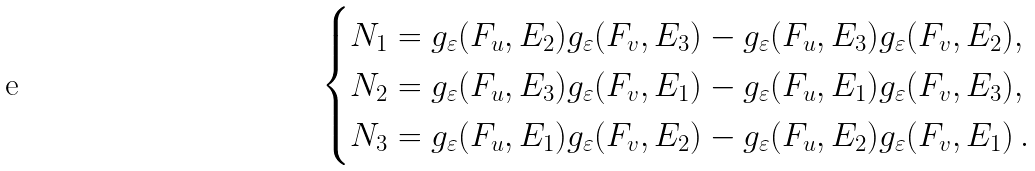Convert formula to latex. <formula><loc_0><loc_0><loc_500><loc_500>\begin{cases} N _ { 1 } = g _ { \varepsilon } ( F _ { u } , E _ { 2 } ) g _ { \varepsilon } ( F _ { v } , E _ { 3 } ) - g _ { \varepsilon } ( F _ { u } , E _ { 3 } ) g _ { \varepsilon } ( F _ { v } , E _ { 2 } ) , \\ N _ { 2 } = g _ { \varepsilon } ( F _ { u } , E _ { 3 } ) g _ { \varepsilon } ( F _ { v } , E _ { 1 } ) - g _ { \varepsilon } ( F _ { u } , E _ { 1 } ) g _ { \varepsilon } ( F _ { v } , E _ { 3 } ) , \\ N _ { 3 } = g _ { \varepsilon } ( F _ { u } , E _ { 1 } ) g _ { \varepsilon } ( F _ { v } , E _ { 2 } ) - g _ { \varepsilon } ( F _ { u } , E _ { 2 } ) g _ { \varepsilon } ( F _ { v } , E _ { 1 } ) \, . \end{cases}</formula> 